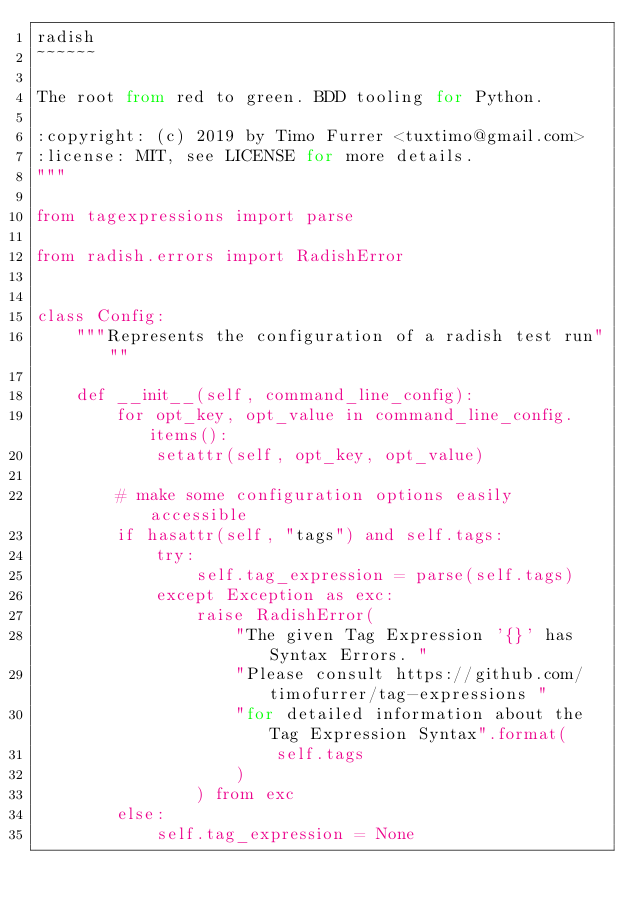Convert code to text. <code><loc_0><loc_0><loc_500><loc_500><_Python_>radish
~~~~~~

The root from red to green. BDD tooling for Python.

:copyright: (c) 2019 by Timo Furrer <tuxtimo@gmail.com>
:license: MIT, see LICENSE for more details.
"""

from tagexpressions import parse

from radish.errors import RadishError


class Config:
    """Represents the configuration of a radish test run"""

    def __init__(self, command_line_config):
        for opt_key, opt_value in command_line_config.items():
            setattr(self, opt_key, opt_value)

        # make some configuration options easily accessible
        if hasattr(self, "tags") and self.tags:
            try:
                self.tag_expression = parse(self.tags)
            except Exception as exc:
                raise RadishError(
                    "The given Tag Expression '{}' has Syntax Errors. "
                    "Please consult https://github.com/timofurrer/tag-expressions "
                    "for detailed information about the Tag Expression Syntax".format(
                        self.tags
                    )
                ) from exc
        else:
            self.tag_expression = None
</code> 